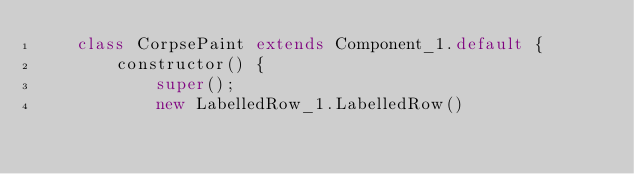Convert code to text. <code><loc_0><loc_0><loc_500><loc_500><_JavaScript_>    class CorpsePaint extends Component_1.default {
        constructor() {
            super();
            new LabelledRow_1.LabelledRow()</code> 